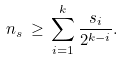<formula> <loc_0><loc_0><loc_500><loc_500>n _ { s } \, \geq \, \sum _ { i = 1 } ^ { k } \frac { s _ { i } } { 2 ^ { k - i } } .</formula> 